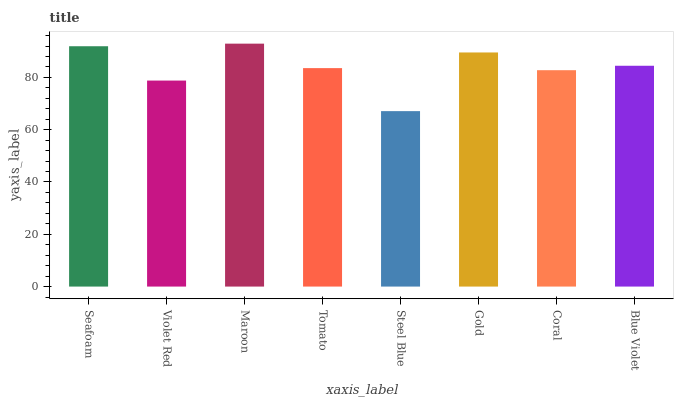Is Steel Blue the minimum?
Answer yes or no. Yes. Is Maroon the maximum?
Answer yes or no. Yes. Is Violet Red the minimum?
Answer yes or no. No. Is Violet Red the maximum?
Answer yes or no. No. Is Seafoam greater than Violet Red?
Answer yes or no. Yes. Is Violet Red less than Seafoam?
Answer yes or no. Yes. Is Violet Red greater than Seafoam?
Answer yes or no. No. Is Seafoam less than Violet Red?
Answer yes or no. No. Is Blue Violet the high median?
Answer yes or no. Yes. Is Tomato the low median?
Answer yes or no. Yes. Is Coral the high median?
Answer yes or no. No. Is Gold the low median?
Answer yes or no. No. 